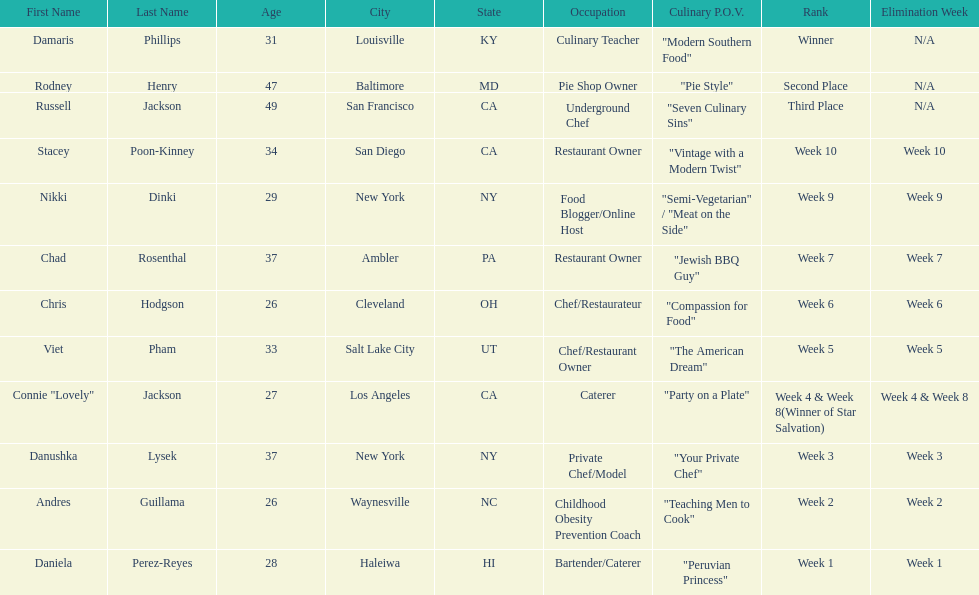Which contestant is the same age as chris hodgson? Andres Guillama. 